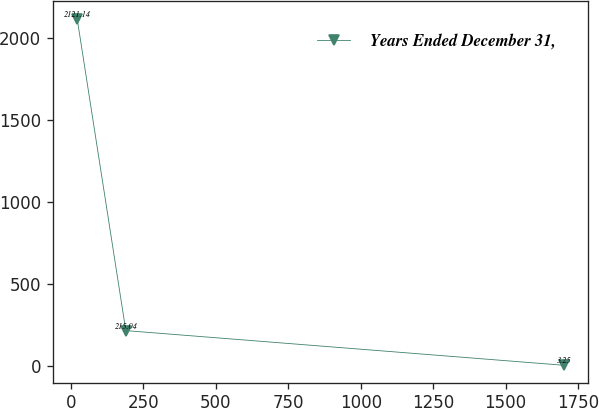<chart> <loc_0><loc_0><loc_500><loc_500><line_chart><ecel><fcel>Years Ended December 31,<nl><fcel>21.4<fcel>2121.14<nl><fcel>189.29<fcel>215.04<nl><fcel>1700.31<fcel>3.25<nl></chart> 